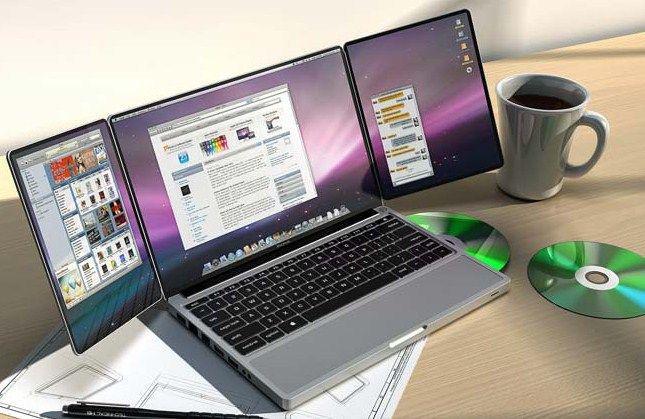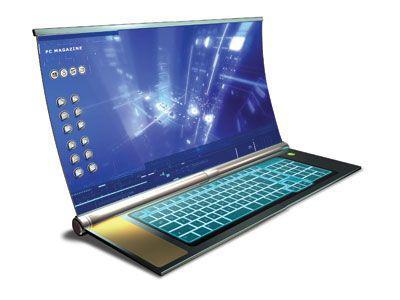The first image is the image on the left, the second image is the image on the right. Evaluate the accuracy of this statement regarding the images: "The laptop on the right has a slightly curved, concave screen.". Is it true? Answer yes or no. Yes. 